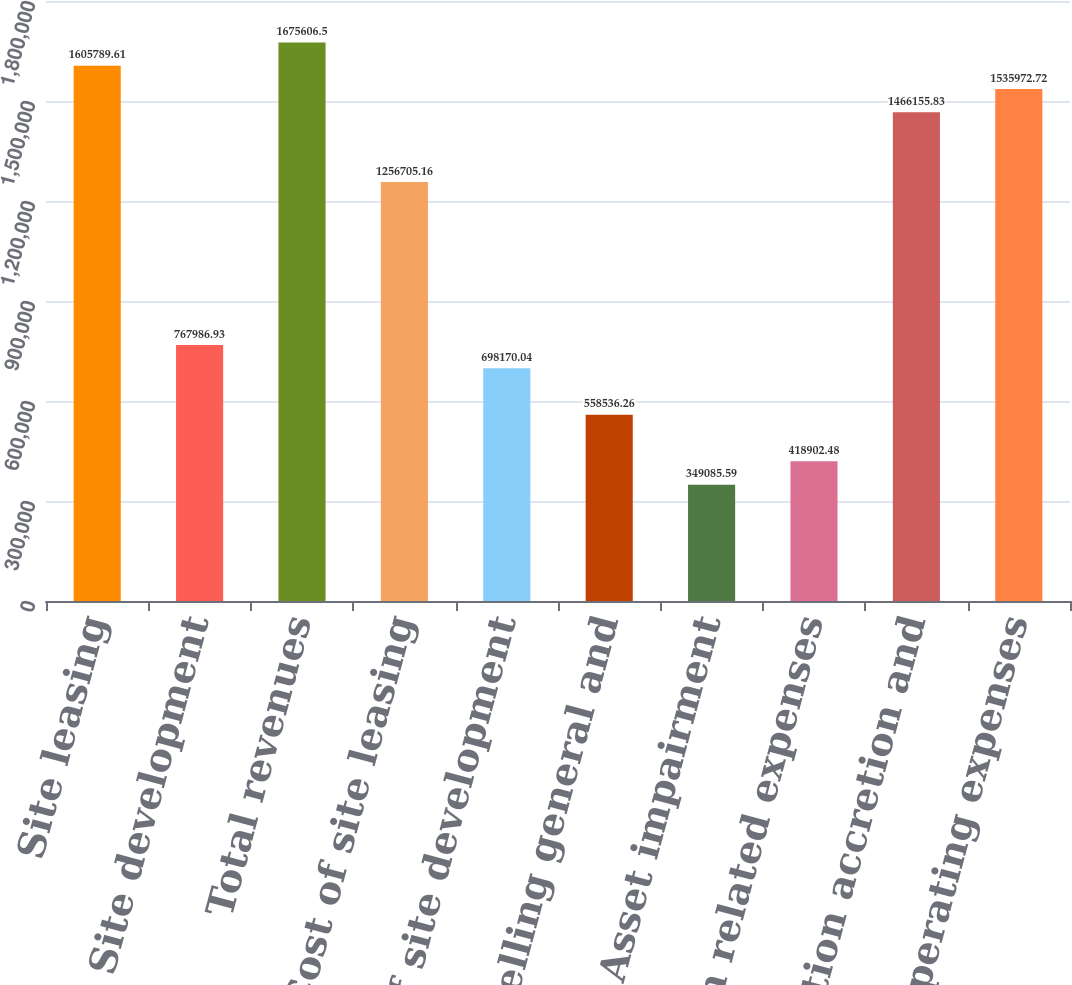<chart> <loc_0><loc_0><loc_500><loc_500><bar_chart><fcel>Site leasing<fcel>Site development<fcel>Total revenues<fcel>Cost of site leasing<fcel>Cost of site development<fcel>Selling general and<fcel>Asset impairment<fcel>Acquisition related expenses<fcel>Depreciation accretion and<fcel>Total operating expenses<nl><fcel>1.60579e+06<fcel>767987<fcel>1.67561e+06<fcel>1.25671e+06<fcel>698170<fcel>558536<fcel>349086<fcel>418902<fcel>1.46616e+06<fcel>1.53597e+06<nl></chart> 